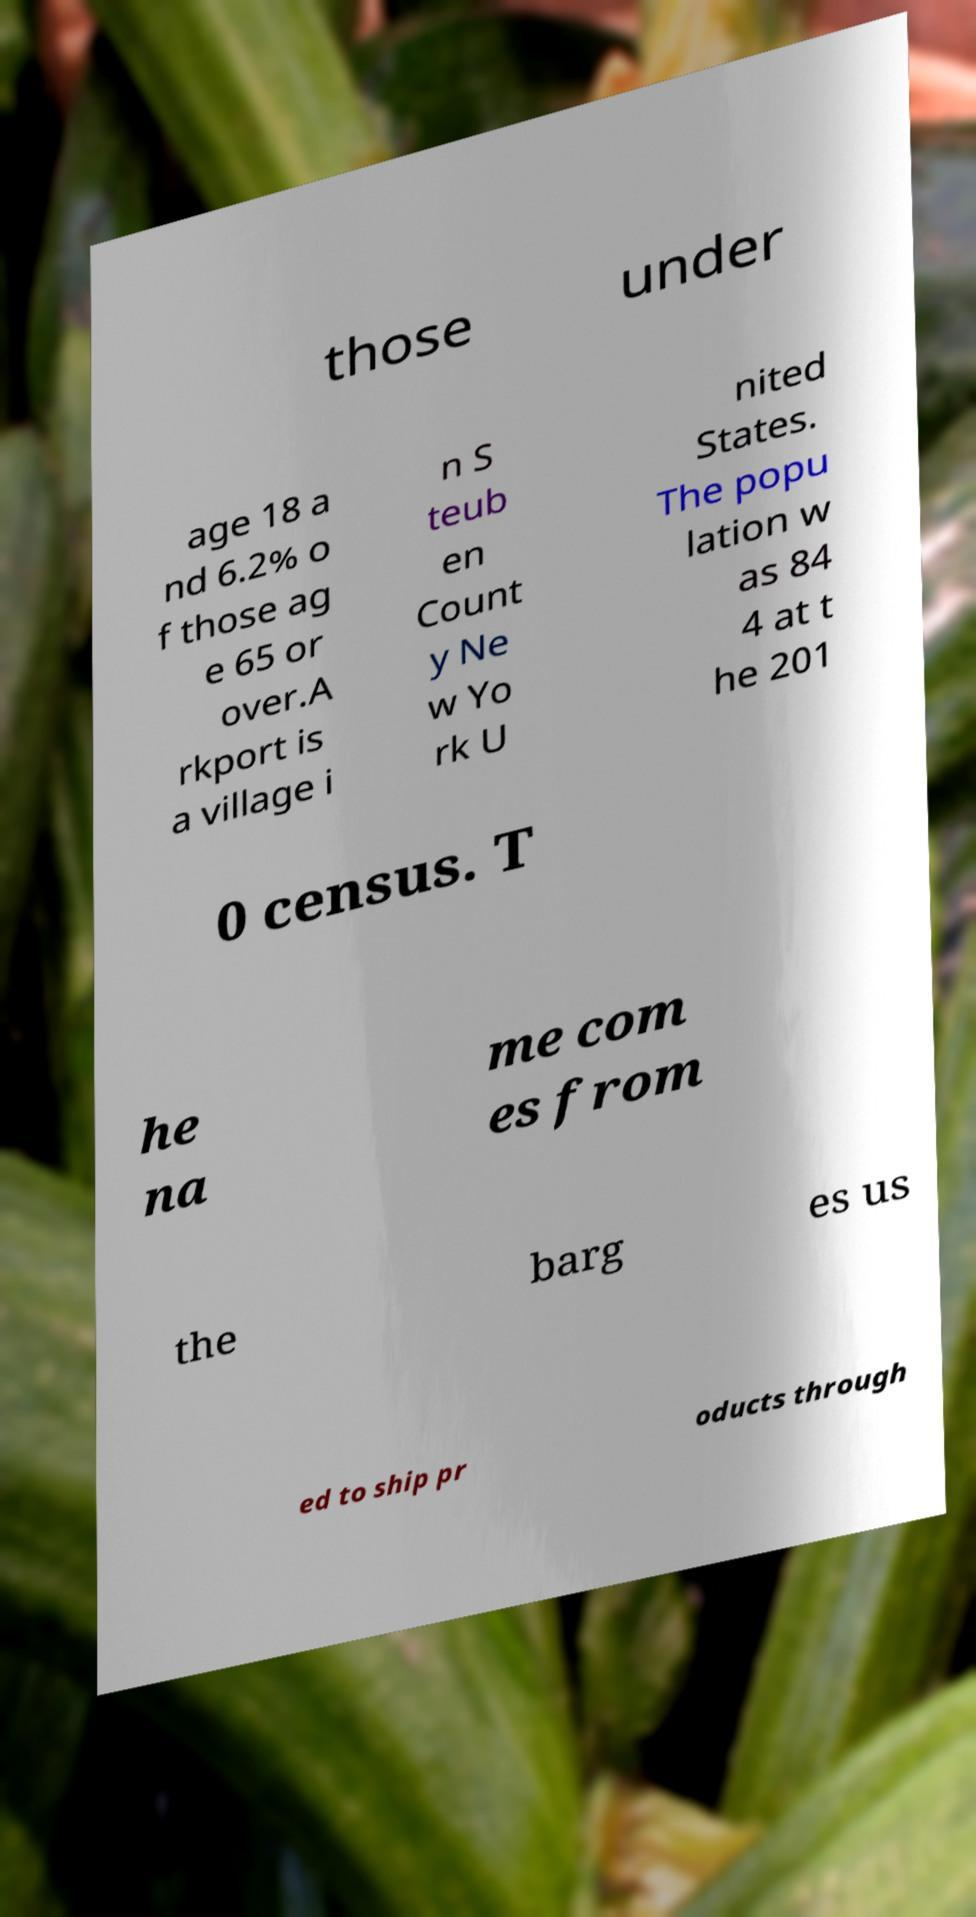Can you read and provide the text displayed in the image?This photo seems to have some interesting text. Can you extract and type it out for me? those under age 18 a nd 6.2% o f those ag e 65 or over.A rkport is a village i n S teub en Count y Ne w Yo rk U nited States. The popu lation w as 84 4 at t he 201 0 census. T he na me com es from the barg es us ed to ship pr oducts through 